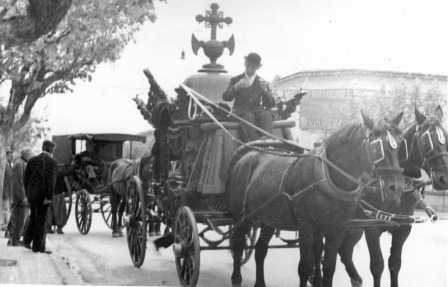Describe the objects in this image and their specific colors. I can see horse in darkgray, gray, black, and lightgray tones, horse in darkgray, gray, black, and lightgray tones, people in gray, darkgray, and lightgray tones, people in darkgray, black, gray, and lightgray tones, and horse in darkgray, black, gray, and lightgray tones in this image. 